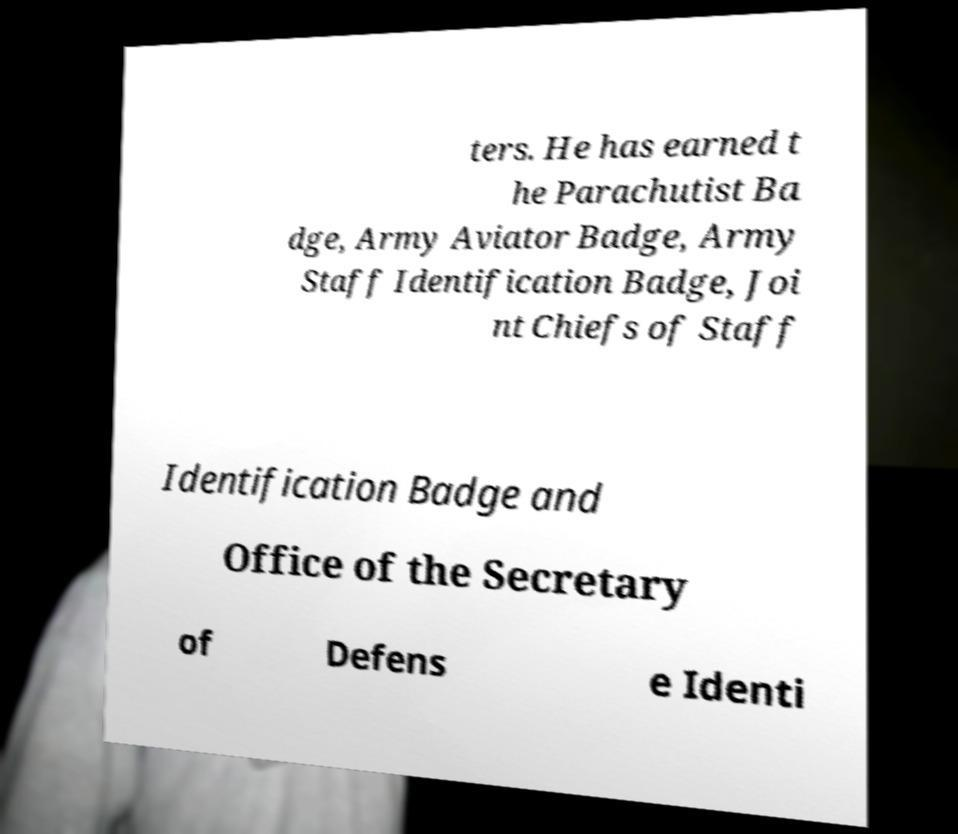There's text embedded in this image that I need extracted. Can you transcribe it verbatim? ters. He has earned t he Parachutist Ba dge, Army Aviator Badge, Army Staff Identification Badge, Joi nt Chiefs of Staff Identification Badge and Office of the Secretary of Defens e Identi 